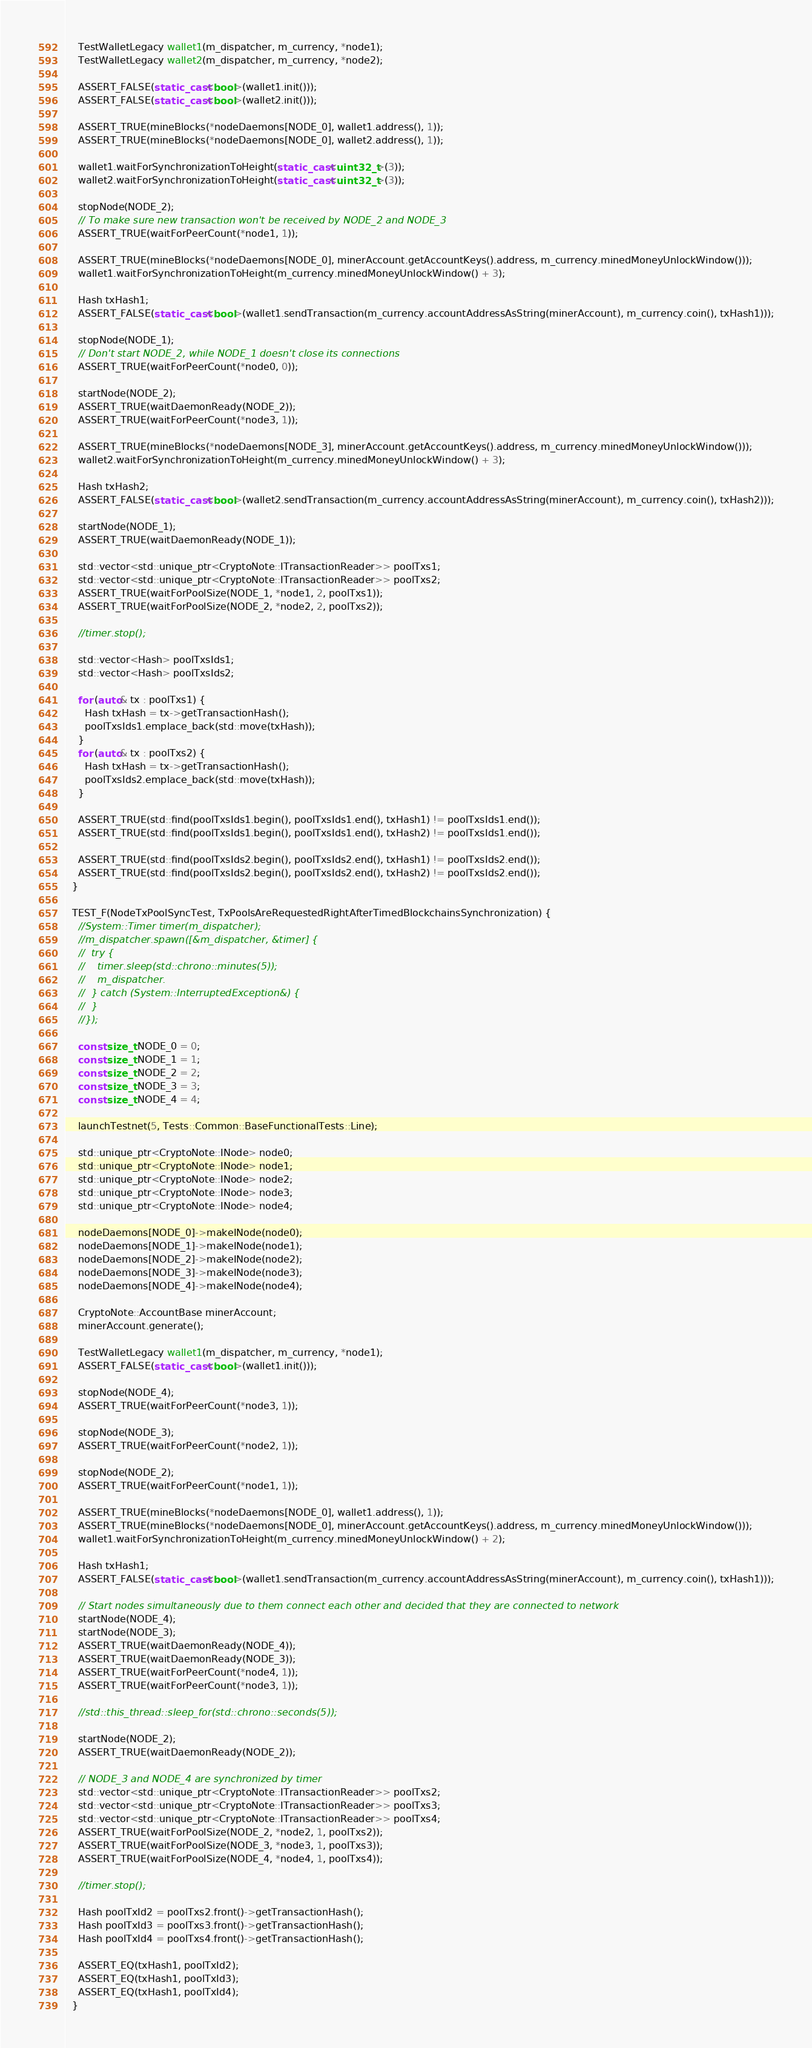<code> <loc_0><loc_0><loc_500><loc_500><_C++_>
    TestWalletLegacy wallet1(m_dispatcher, m_currency, *node1);
    TestWalletLegacy wallet2(m_dispatcher, m_currency, *node2);

    ASSERT_FALSE(static_cast<bool>(wallet1.init()));
    ASSERT_FALSE(static_cast<bool>(wallet2.init()));

    ASSERT_TRUE(mineBlocks(*nodeDaemons[NODE_0], wallet1.address(), 1));
    ASSERT_TRUE(mineBlocks(*nodeDaemons[NODE_0], wallet2.address(), 1));

    wallet1.waitForSynchronizationToHeight(static_cast<uint32_t>(3));
    wallet2.waitForSynchronizationToHeight(static_cast<uint32_t>(3));

    stopNode(NODE_2);
    // To make sure new transaction won't be received by NODE_2 and NODE_3
    ASSERT_TRUE(waitForPeerCount(*node1, 1));

    ASSERT_TRUE(mineBlocks(*nodeDaemons[NODE_0], minerAccount.getAccountKeys().address, m_currency.minedMoneyUnlockWindow()));
    wallet1.waitForSynchronizationToHeight(m_currency.minedMoneyUnlockWindow() + 3);

    Hash txHash1;
    ASSERT_FALSE(static_cast<bool>(wallet1.sendTransaction(m_currency.accountAddressAsString(minerAccount), m_currency.coin(), txHash1)));

    stopNode(NODE_1);
    // Don't start NODE_2, while NODE_1 doesn't close its connections
    ASSERT_TRUE(waitForPeerCount(*node0, 0));

    startNode(NODE_2);
    ASSERT_TRUE(waitDaemonReady(NODE_2));
    ASSERT_TRUE(waitForPeerCount(*node3, 1));

    ASSERT_TRUE(mineBlocks(*nodeDaemons[NODE_3], minerAccount.getAccountKeys().address, m_currency.minedMoneyUnlockWindow()));
    wallet2.waitForSynchronizationToHeight(m_currency.minedMoneyUnlockWindow() + 3);

    Hash txHash2;
    ASSERT_FALSE(static_cast<bool>(wallet2.sendTransaction(m_currency.accountAddressAsString(minerAccount), m_currency.coin(), txHash2)));

    startNode(NODE_1);
    ASSERT_TRUE(waitDaemonReady(NODE_1));

    std::vector<std::unique_ptr<CryptoNote::ITransactionReader>> poolTxs1;
    std::vector<std::unique_ptr<CryptoNote::ITransactionReader>> poolTxs2;
    ASSERT_TRUE(waitForPoolSize(NODE_1, *node1, 2, poolTxs1));
    ASSERT_TRUE(waitForPoolSize(NODE_2, *node2, 2, poolTxs2));

    //timer.stop();

    std::vector<Hash> poolTxsIds1;
    std::vector<Hash> poolTxsIds2;

    for (auto& tx : poolTxs1) {
      Hash txHash = tx->getTransactionHash();
      poolTxsIds1.emplace_back(std::move(txHash));
    }
    for (auto& tx : poolTxs2) {
      Hash txHash = tx->getTransactionHash();
      poolTxsIds2.emplace_back(std::move(txHash));
    }

    ASSERT_TRUE(std::find(poolTxsIds1.begin(), poolTxsIds1.end(), txHash1) != poolTxsIds1.end());
    ASSERT_TRUE(std::find(poolTxsIds1.begin(), poolTxsIds1.end(), txHash2) != poolTxsIds1.end());

    ASSERT_TRUE(std::find(poolTxsIds2.begin(), poolTxsIds2.end(), txHash1) != poolTxsIds2.end());
    ASSERT_TRUE(std::find(poolTxsIds2.begin(), poolTxsIds2.end(), txHash2) != poolTxsIds2.end());
  }

  TEST_F(NodeTxPoolSyncTest, TxPoolsAreRequestedRightAfterTimedBlockchainsSynchronization) {
    //System::Timer timer(m_dispatcher);
    //m_dispatcher.spawn([&m_dispatcher, &timer] {
    //  try {
    //    timer.sleep(std::chrono::minutes(5));
    //    m_dispatcher.
    //  } catch (System::InterruptedException&) {
    //  }
    //});

    const size_t NODE_0 = 0;
    const size_t NODE_1 = 1;
    const size_t NODE_2 = 2;
    const size_t NODE_3 = 3;
    const size_t NODE_4 = 4;

    launchTestnet(5, Tests::Common::BaseFunctionalTests::Line);

    std::unique_ptr<CryptoNote::INode> node0;
    std::unique_ptr<CryptoNote::INode> node1;
    std::unique_ptr<CryptoNote::INode> node2;
    std::unique_ptr<CryptoNote::INode> node3;
    std::unique_ptr<CryptoNote::INode> node4;

    nodeDaemons[NODE_0]->makeINode(node0);
    nodeDaemons[NODE_1]->makeINode(node1);
    nodeDaemons[NODE_2]->makeINode(node2);
    nodeDaemons[NODE_3]->makeINode(node3);
    nodeDaemons[NODE_4]->makeINode(node4);

    CryptoNote::AccountBase minerAccount;
    minerAccount.generate();

    TestWalletLegacy wallet1(m_dispatcher, m_currency, *node1);
    ASSERT_FALSE(static_cast<bool>(wallet1.init()));

    stopNode(NODE_4);
    ASSERT_TRUE(waitForPeerCount(*node3, 1));

    stopNode(NODE_3);
    ASSERT_TRUE(waitForPeerCount(*node2, 1));

    stopNode(NODE_2);
    ASSERT_TRUE(waitForPeerCount(*node1, 1));

    ASSERT_TRUE(mineBlocks(*nodeDaemons[NODE_0], wallet1.address(), 1));
    ASSERT_TRUE(mineBlocks(*nodeDaemons[NODE_0], minerAccount.getAccountKeys().address, m_currency.minedMoneyUnlockWindow()));
    wallet1.waitForSynchronizationToHeight(m_currency.minedMoneyUnlockWindow() + 2);

    Hash txHash1;
    ASSERT_FALSE(static_cast<bool>(wallet1.sendTransaction(m_currency.accountAddressAsString(minerAccount), m_currency.coin(), txHash1)));

    // Start nodes simultaneously due to them connect each other and decided that they are connected to network
    startNode(NODE_4);
    startNode(NODE_3);
    ASSERT_TRUE(waitDaemonReady(NODE_4));
    ASSERT_TRUE(waitDaemonReady(NODE_3));
    ASSERT_TRUE(waitForPeerCount(*node4, 1));
    ASSERT_TRUE(waitForPeerCount(*node3, 1));

    //std::this_thread::sleep_for(std::chrono::seconds(5));

    startNode(NODE_2);
    ASSERT_TRUE(waitDaemonReady(NODE_2));

    // NODE_3 and NODE_4 are synchronized by timer
    std::vector<std::unique_ptr<CryptoNote::ITransactionReader>> poolTxs2;
    std::vector<std::unique_ptr<CryptoNote::ITransactionReader>> poolTxs3;
    std::vector<std::unique_ptr<CryptoNote::ITransactionReader>> poolTxs4;
    ASSERT_TRUE(waitForPoolSize(NODE_2, *node2, 1, poolTxs2));
    ASSERT_TRUE(waitForPoolSize(NODE_3, *node3, 1, poolTxs3));
    ASSERT_TRUE(waitForPoolSize(NODE_4, *node4, 1, poolTxs4));

    //timer.stop();

    Hash poolTxId2 = poolTxs2.front()->getTransactionHash();
    Hash poolTxId3 = poolTxs3.front()->getTransactionHash();
    Hash poolTxId4 = poolTxs4.front()->getTransactionHash();

    ASSERT_EQ(txHash1, poolTxId2);
    ASSERT_EQ(txHash1, poolTxId3);
    ASSERT_EQ(txHash1, poolTxId4);
  }
</code> 